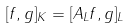Convert formula to latex. <formula><loc_0><loc_0><loc_500><loc_500>[ f , g ] _ { K } = [ A _ { L } f , g ] _ { L }</formula> 